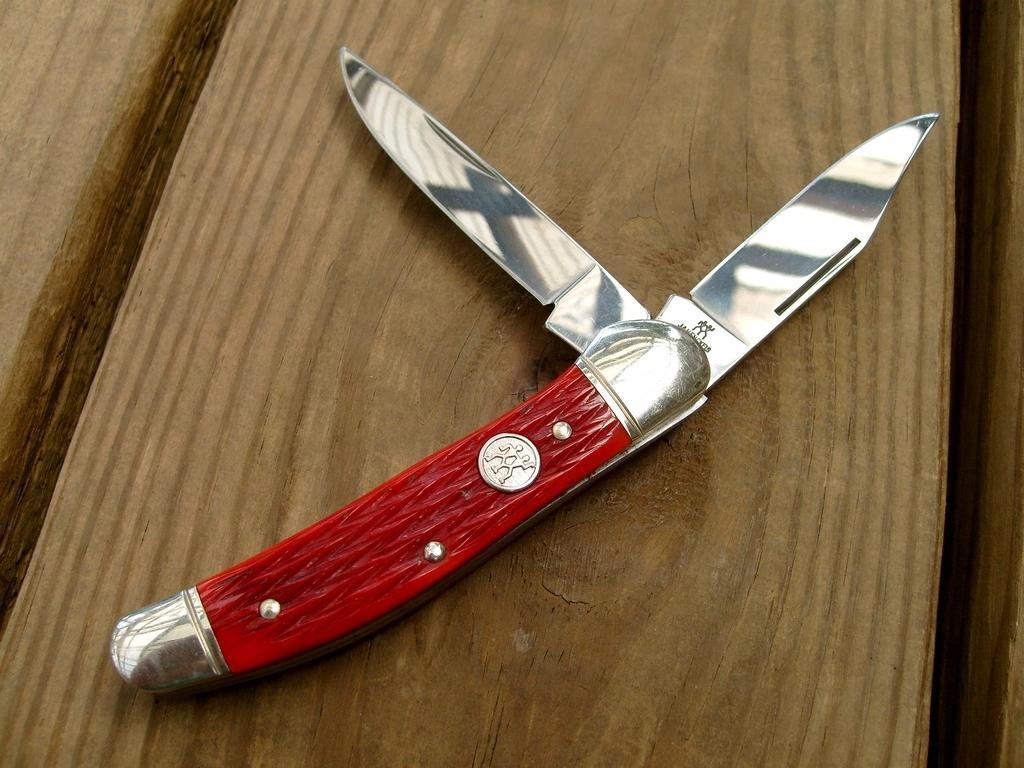Can you describe this image briefly? There is a knife kept on a wooden table and the handle of the knife is in red color. 